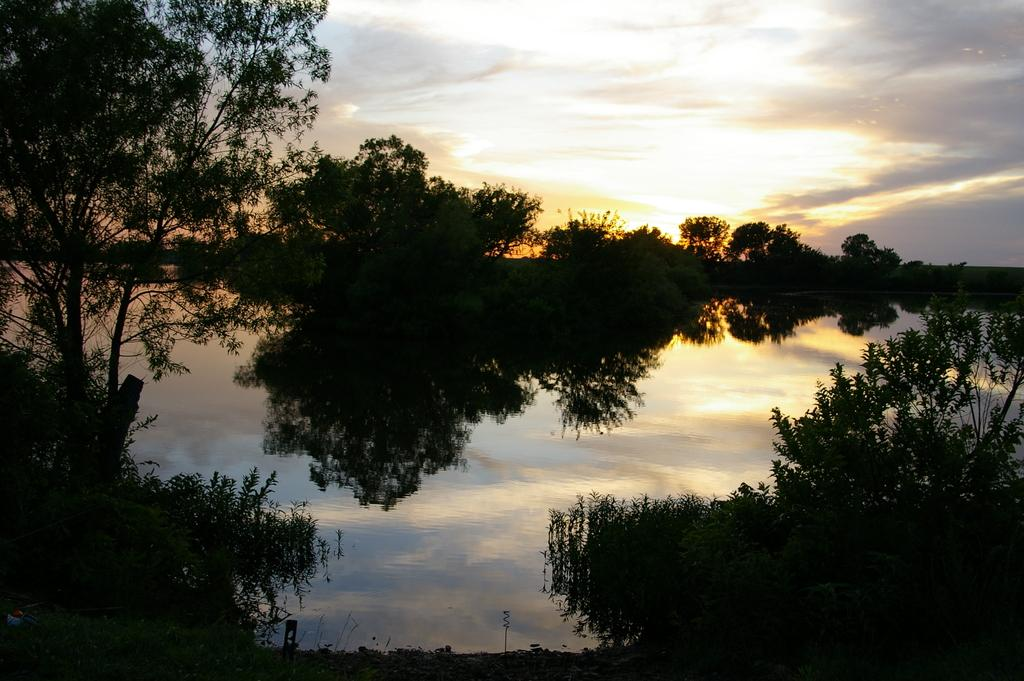What type of natural feature is at the bottom of the image? There is a river at the bottom of the image. What can be found near the river? There are plants near the river. What is visible in the background of the image? There are trees in the background of the image. What is visible at the top of the image? The sky is visible at the top of the image. What type of furniture can be seen floating in the river in the image? There is no furniture visible in the image; it only features a river, plants, trees, and the sky. 